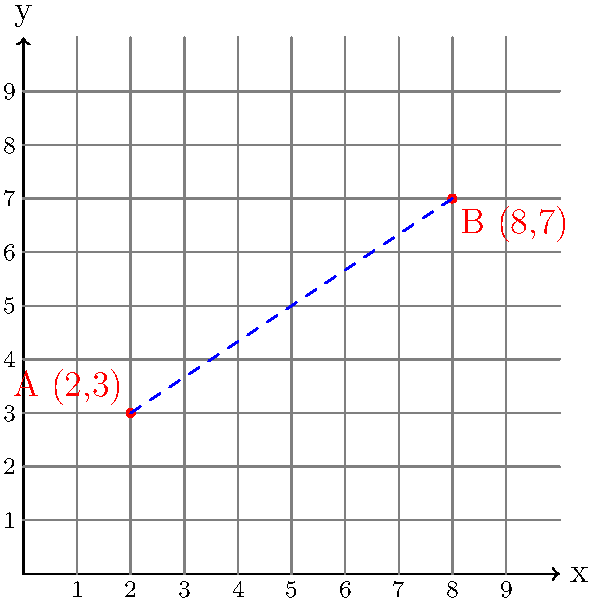As a cybersecurity expert, you're analyzing the physical layout of a network. Two critical nodes, A and B, are positioned on a coordinate plane as shown in the diagram. Node A is located at (2,3) and Node B is at (8,7). To assess the potential for a direct line-of-sight wireless connection, you need to calculate the exact distance between these nodes. What is the distance between Node A and Node B? To solve this problem, we'll use the distance formula derived from the Pythagorean theorem:

1) The distance formula is:
   $$d = \sqrt{(x_2-x_1)^2 + (y_2-y_1)^2}$$
   where $(x_1,y_1)$ is the coordinate of point A and $(x_2,y_2)$ is the coordinate of point B.

2) We have:
   A (2,3) and B (8,7)
   So, $x_1 = 2$, $y_1 = 3$, $x_2 = 8$, and $y_2 = 7$

3) Let's substitute these values into the formula:
   $$d = \sqrt{(8-2)^2 + (7-3)^2}$$

4) Simplify inside the parentheses:
   $$d = \sqrt{6^2 + 4^2}$$

5) Calculate the squares:
   $$d = \sqrt{36 + 16}$$

6) Add under the square root:
   $$d = \sqrt{52}$$

7) Simplify the square root:
   $$d = 2\sqrt{13}$$

This is the exact distance between the two nodes. If we need a decimal approximation, we can calculate:
   $$d \approx 7.21$$ (rounded to two decimal places)
Answer: $2\sqrt{13}$ units (or approximately 7.21 units) 